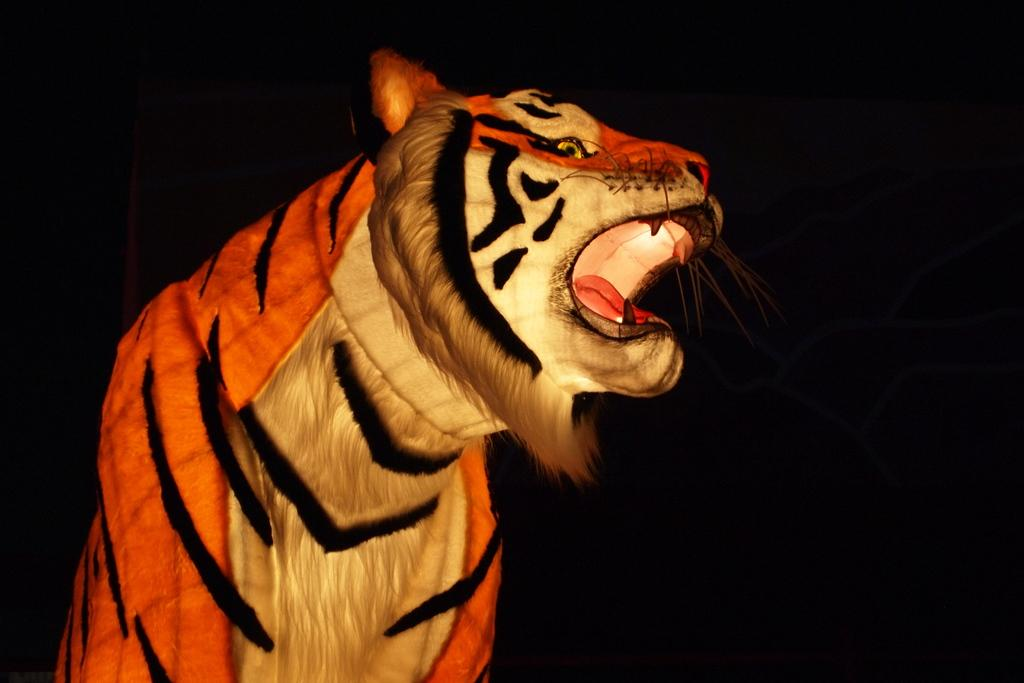Who or what is the main subject in the image? There is a person in the image. What is the person wearing in the image? The person is wearing a tiger costume. Can you describe the person's location in the image? The person is present over a place. What is the profit margin of the tiger costume in the image? There is no information about the profit margin of the tiger costume in the image, as it is a static image and not a commercial context. 